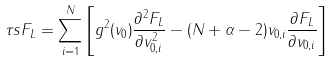<formula> <loc_0><loc_0><loc_500><loc_500>\tau s F _ { L } = \sum _ { i = 1 } ^ { N } \left [ g ^ { 2 } ( v _ { 0 } ) \frac { \partial ^ { 2 } F _ { L } } { \partial v ^ { 2 } _ { 0 , i } } - ( N + \alpha - 2 ) v _ { 0 , i } \frac { \partial F _ { L } } { \partial v _ { 0 , i } } \right ]</formula> 